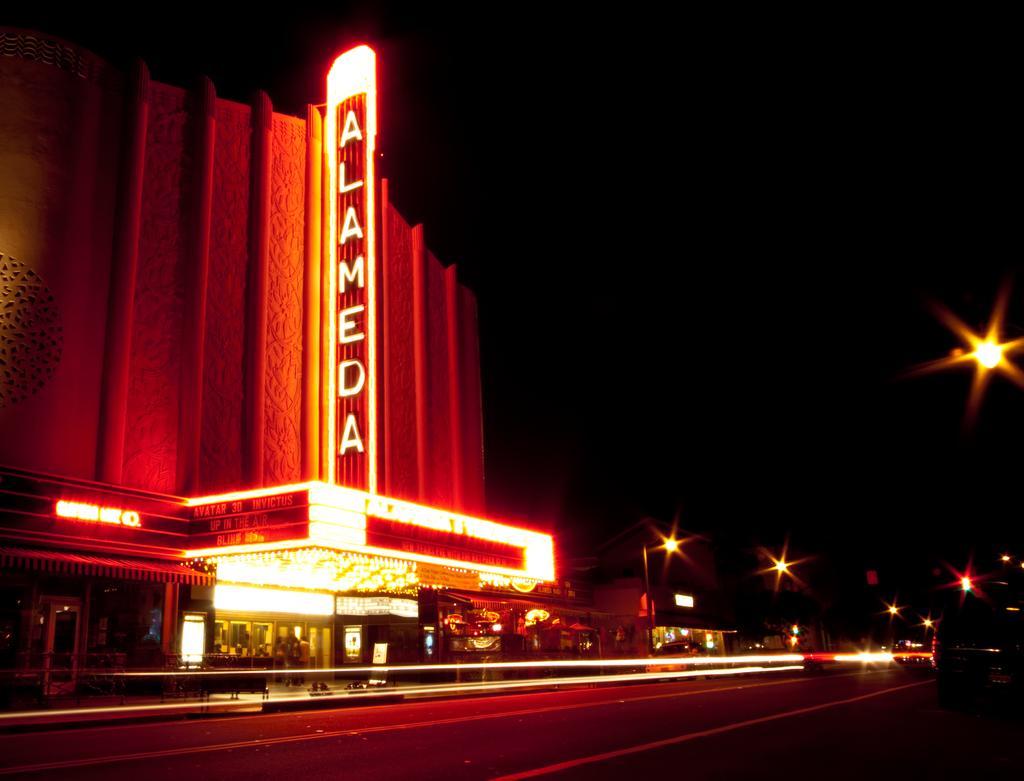Describe this image in one or two sentences. In this image I can see buildings,stores and lights. I can see an orange and red color lighting and background is in black color. 